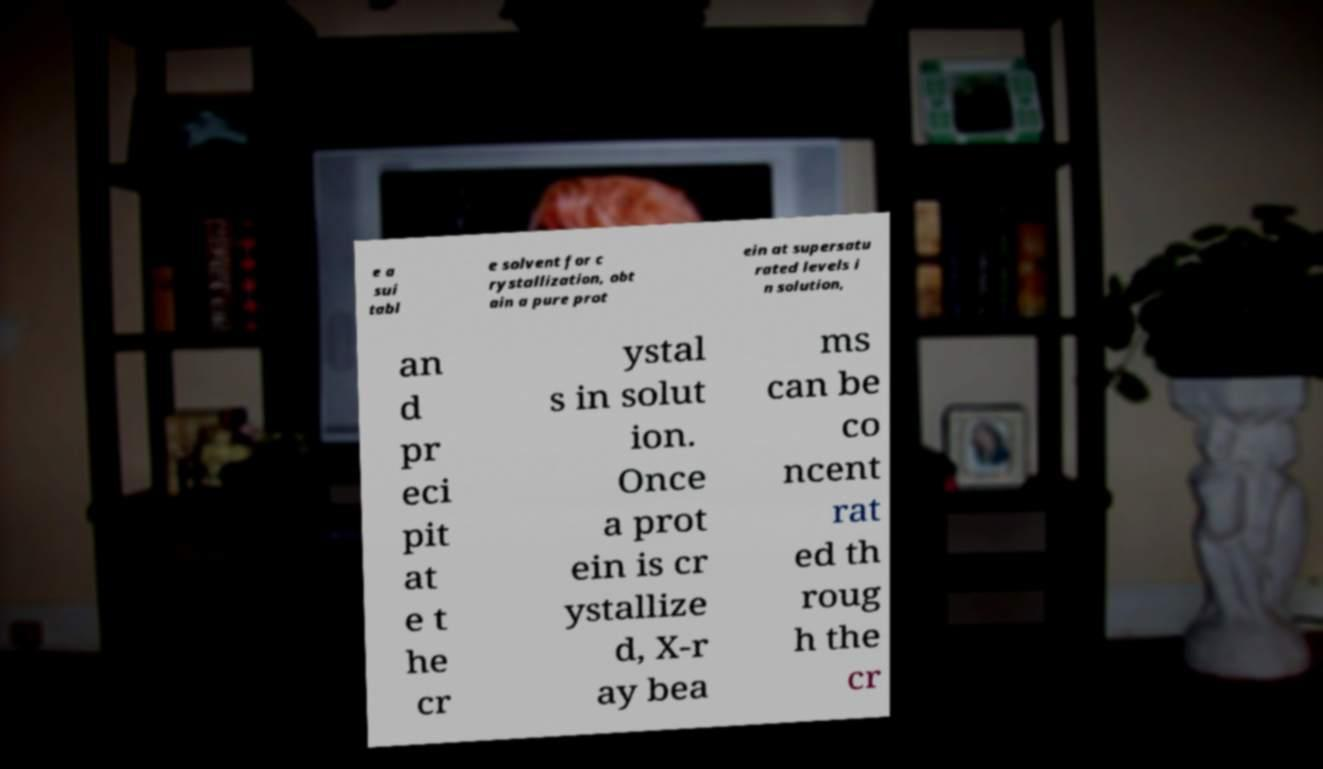For documentation purposes, I need the text within this image transcribed. Could you provide that? e a sui tabl e solvent for c rystallization, obt ain a pure prot ein at supersatu rated levels i n solution, an d pr eci pit at e t he cr ystal s in solut ion. Once a prot ein is cr ystallize d, X-r ay bea ms can be co ncent rat ed th roug h the cr 